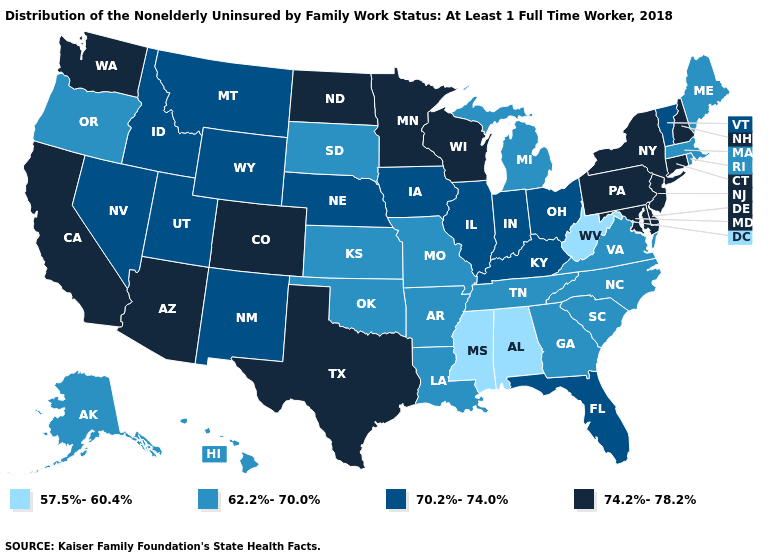What is the value of South Dakota?
Short answer required. 62.2%-70.0%. What is the value of New Hampshire?
Short answer required. 74.2%-78.2%. Among the states that border Indiana , which have the lowest value?
Quick response, please. Michigan. What is the lowest value in the USA?
Be succinct. 57.5%-60.4%. Name the states that have a value in the range 62.2%-70.0%?
Short answer required. Alaska, Arkansas, Georgia, Hawaii, Kansas, Louisiana, Maine, Massachusetts, Michigan, Missouri, North Carolina, Oklahoma, Oregon, Rhode Island, South Carolina, South Dakota, Tennessee, Virginia. Name the states that have a value in the range 57.5%-60.4%?
Write a very short answer. Alabama, Mississippi, West Virginia. What is the lowest value in the USA?
Concise answer only. 57.5%-60.4%. Does Pennsylvania have the highest value in the Northeast?
Answer briefly. Yes. Which states have the highest value in the USA?
Answer briefly. Arizona, California, Colorado, Connecticut, Delaware, Maryland, Minnesota, New Hampshire, New Jersey, New York, North Dakota, Pennsylvania, Texas, Washington, Wisconsin. Which states have the highest value in the USA?
Keep it brief. Arizona, California, Colorado, Connecticut, Delaware, Maryland, Minnesota, New Hampshire, New Jersey, New York, North Dakota, Pennsylvania, Texas, Washington, Wisconsin. Does the map have missing data?
Answer briefly. No. Name the states that have a value in the range 70.2%-74.0%?
Give a very brief answer. Florida, Idaho, Illinois, Indiana, Iowa, Kentucky, Montana, Nebraska, Nevada, New Mexico, Ohio, Utah, Vermont, Wyoming. Does Washington have the highest value in the West?
Answer briefly. Yes. Name the states that have a value in the range 57.5%-60.4%?
Keep it brief. Alabama, Mississippi, West Virginia. 